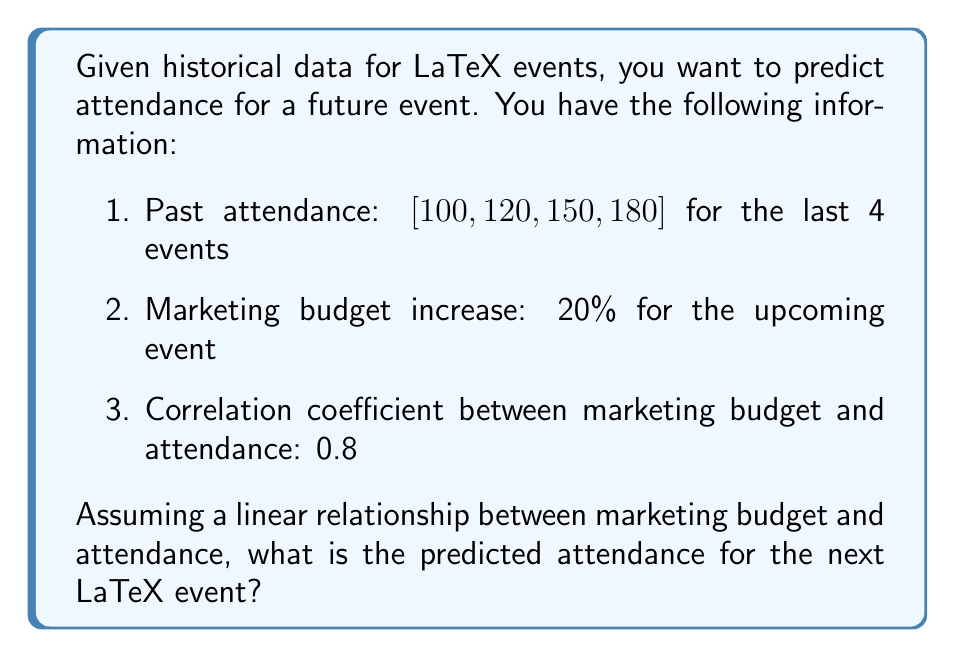Can you solve this math problem? To solve this inverse problem, we'll use the following steps:

1. Calculate the average attendance growth rate:
   $$r = \frac{180 - 100}{100 \cdot 3} = 0.2667 \text{ or } 26.67\% \text{ per event}$$

2. Estimate the base attendance without additional marketing:
   $$A_{\text{base}} = 180 \cdot (1 + 0.2667) = 228$$

3. Calculate the impact of increased marketing budget:
   - Marketing budget increase: 20%
   - Correlation coefficient: 0.8
   - Estimated attendance increase: $20\% \cdot 0.8 = 16\%$

4. Apply the marketing impact to the base attendance:
   $$A_{\text{predicted}} = A_{\text{base}} \cdot (1 + 0.16)$$
   $$A_{\text{predicted}} = 228 \cdot 1.16 = 264.48$$

5. Round to the nearest whole number:
   $$A_{\text{final}} = 264$$
Answer: 264 attendees 